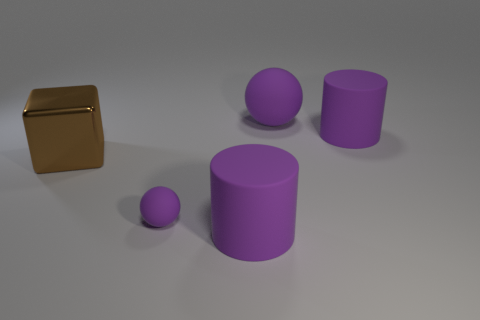Is there anything else that is made of the same material as the large brown cube?
Your answer should be compact. No. What is the color of the tiny sphere that is the same material as the large purple sphere?
Your response must be concise. Purple. Do the rubber ball that is behind the metallic object and the tiny purple rubber object have the same size?
Make the answer very short. No. Is the material of the brown block the same as the purple cylinder that is in front of the shiny object?
Make the answer very short. No. What is the color of the big cylinder behind the brown block?
Ensure brevity in your answer.  Purple. There is a big purple object in front of the tiny purple rubber thing; is there a big brown object that is on the right side of it?
Provide a short and direct response. No. Does the big rubber thing that is left of the big purple ball have the same color as the big matte cylinder that is behind the big shiny object?
Your response must be concise. Yes. There is a big purple matte sphere; how many big purple things are left of it?
Offer a terse response. 1. What number of large metallic objects are the same color as the small thing?
Offer a very short reply. 0. Do the purple sphere that is in front of the metal thing and the large block have the same material?
Your answer should be very brief. No. 